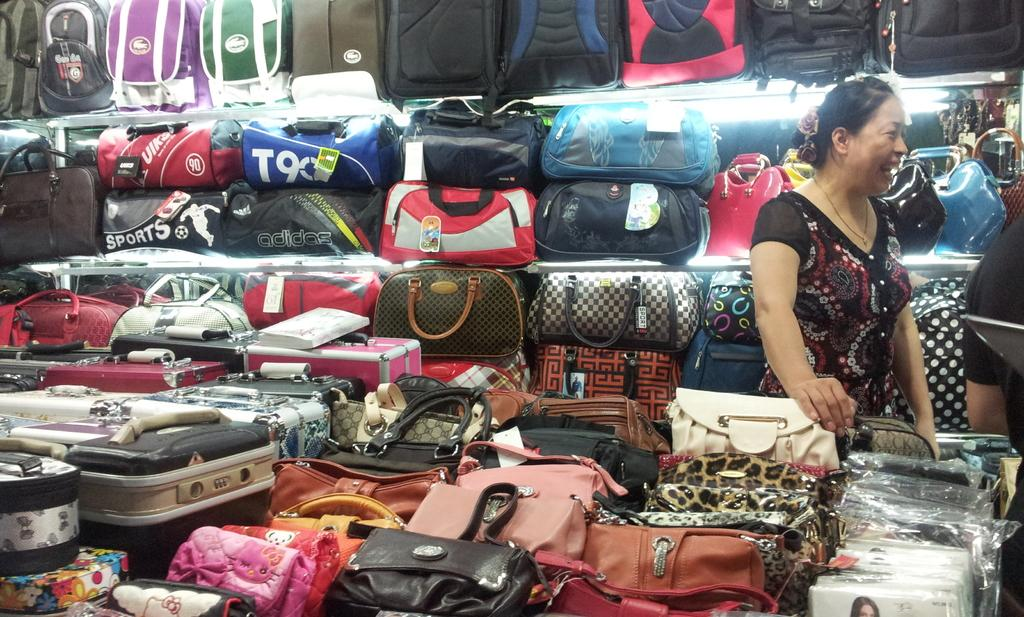Who is present in the image? There is a woman in the image. What is the woman wearing? The woman is wearing a black dress. What is the woman holding in the image? The woman is holding a bag. What other types of bags can be seen in the room? There are handbags and luggage bags in the room. What type of beam does the woman use to whistle in the image? There is no beam or whistling present in the image. 